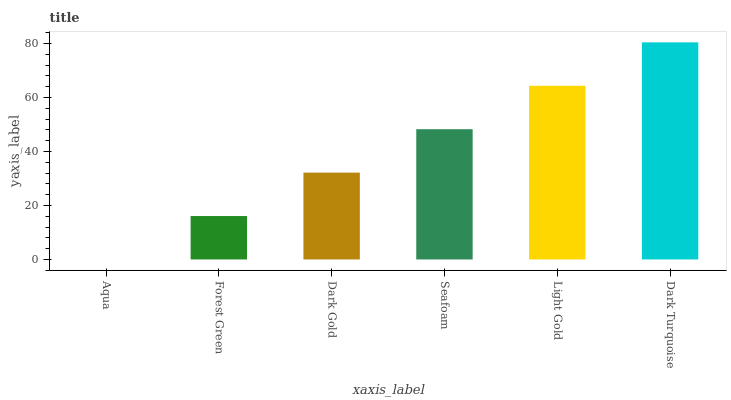Is Aqua the minimum?
Answer yes or no. Yes. Is Dark Turquoise the maximum?
Answer yes or no. Yes. Is Forest Green the minimum?
Answer yes or no. No. Is Forest Green the maximum?
Answer yes or no. No. Is Forest Green greater than Aqua?
Answer yes or no. Yes. Is Aqua less than Forest Green?
Answer yes or no. Yes. Is Aqua greater than Forest Green?
Answer yes or no. No. Is Forest Green less than Aqua?
Answer yes or no. No. Is Seafoam the high median?
Answer yes or no. Yes. Is Dark Gold the low median?
Answer yes or no. Yes. Is Light Gold the high median?
Answer yes or no. No. Is Seafoam the low median?
Answer yes or no. No. 